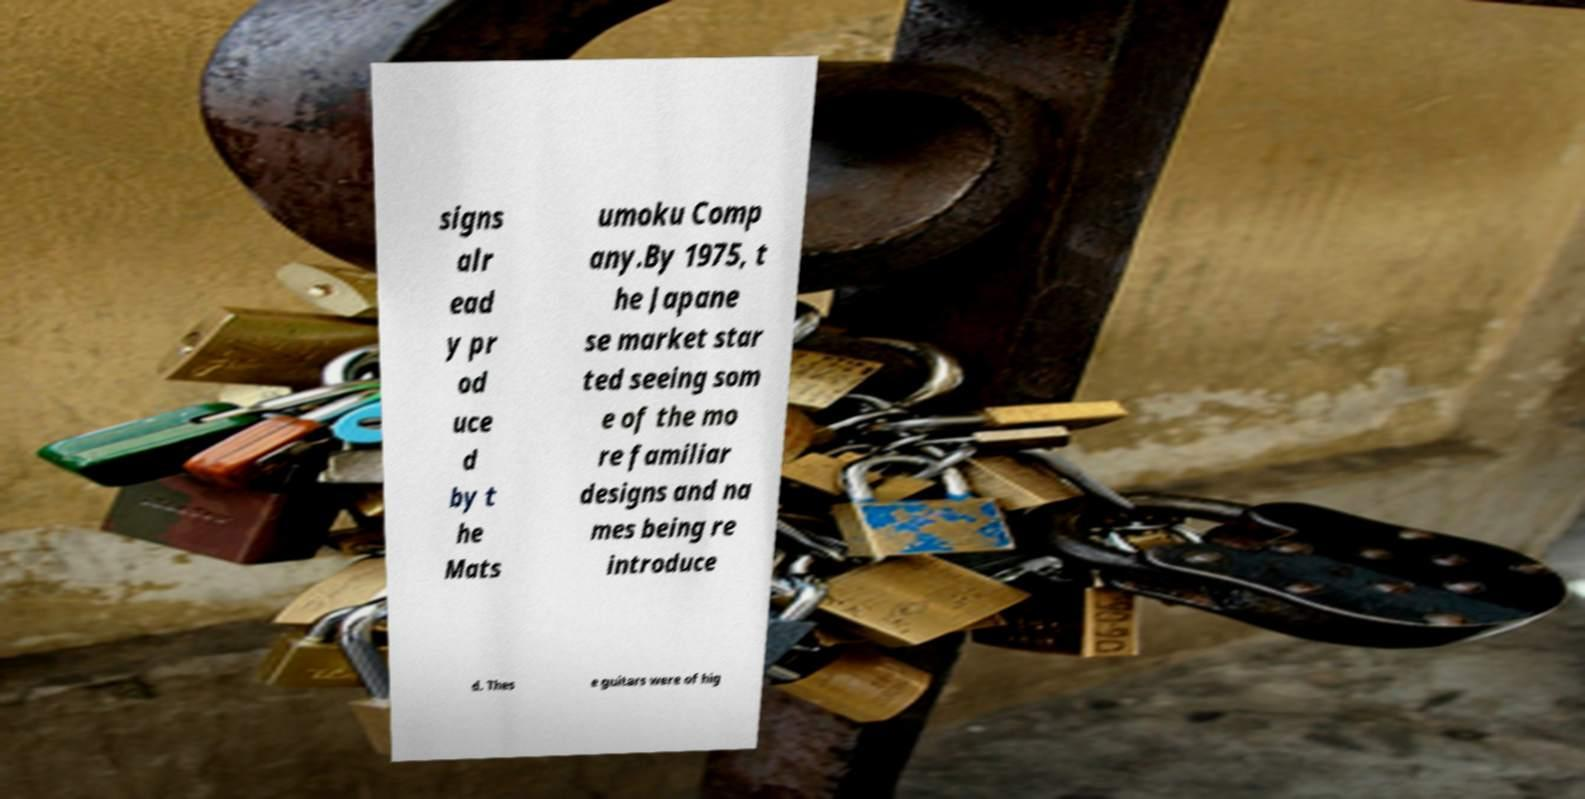Can you read and provide the text displayed in the image?This photo seems to have some interesting text. Can you extract and type it out for me? signs alr ead y pr od uce d by t he Mats umoku Comp any.By 1975, t he Japane se market star ted seeing som e of the mo re familiar designs and na mes being re introduce d. Thes e guitars were of hig 